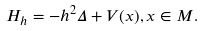Convert formula to latex. <formula><loc_0><loc_0><loc_500><loc_500>H _ { h } = - h ^ { 2 } \Delta + V ( x ) , x \in M .</formula> 